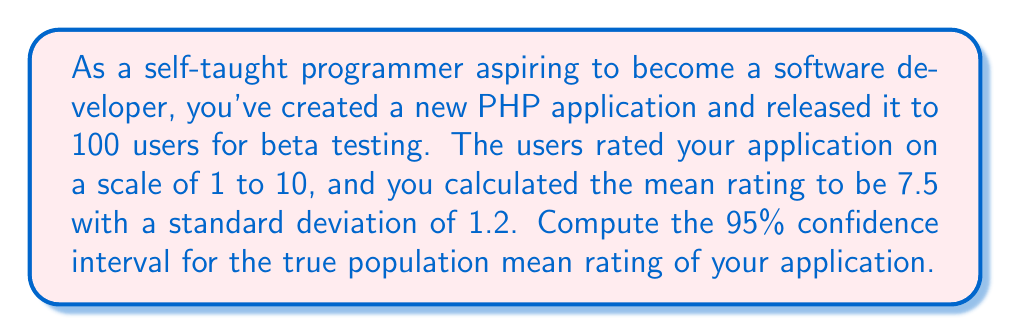Solve this math problem. To compute the confidence interval, we'll follow these steps:

1. Identify the given information:
   - Sample size: $n = 100$
   - Sample mean: $\bar{x} = 7.5$
   - Sample standard deviation: $s = 1.2$
   - Confidence level: 95% (α = 0.05)

2. Determine the critical value:
   For a 95% confidence interval, we use the t-distribution with $n-1 = 99$ degrees of freedom.
   The critical value is $t_{0.025,99} = 1.984$ (you can find this using a t-table or statistical software).

3. Calculate the margin of error:
   Margin of error = $t_{0.025,99} \cdot \frac{s}{\sqrt{n}}$
   $$ \text{Margin of error} = 1.984 \cdot \frac{1.2}{\sqrt{100}} = 1.984 \cdot 0.12 = 0.238 $$

4. Compute the confidence interval:
   The formula for the confidence interval is:
   $$ \text{CI} = \bar{x} \pm \text{Margin of error} $$
   
   Lower bound: $7.5 - 0.238 = 7.262$
   Upper bound: $7.5 + 0.238 = 7.738$

Therefore, the 95% confidence interval for the true population mean rating of your application is (7.262, 7.738).

This means we can be 95% confident that the true population mean rating for your PHP application falls between 7.262 and 7.738.
Answer: The 95% confidence interval for the true population mean rating of the PHP application is (7.262, 7.738). 